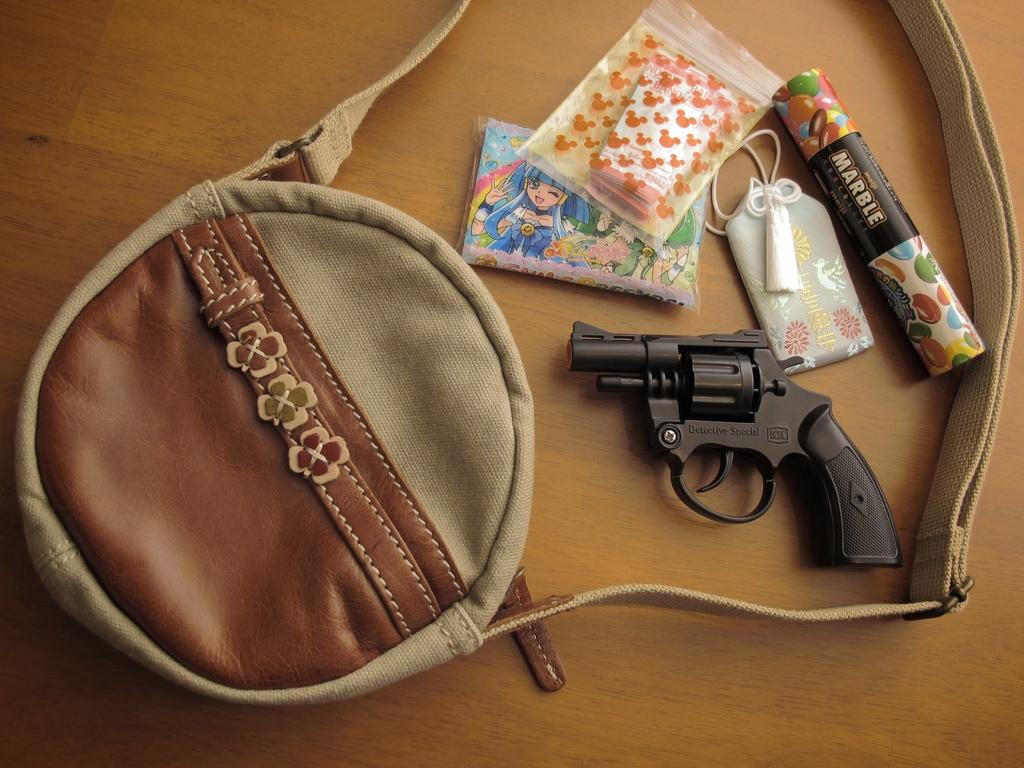What object is placed on the table in the image? There is a bag on the table. What is covering the table in the image? There is a plastic cover on the table. What type of food items can be seen on the table? There are candies on the table. What type of paper object is on the table? There is a card on the table. What potentially dangerous object is on the table? There is a gun on the table. What type of cork can be seen on the table in the image? There is no cork present on the table in the image. How many days are represented by the week on the table in the image? There is no week present on the table in the image. 